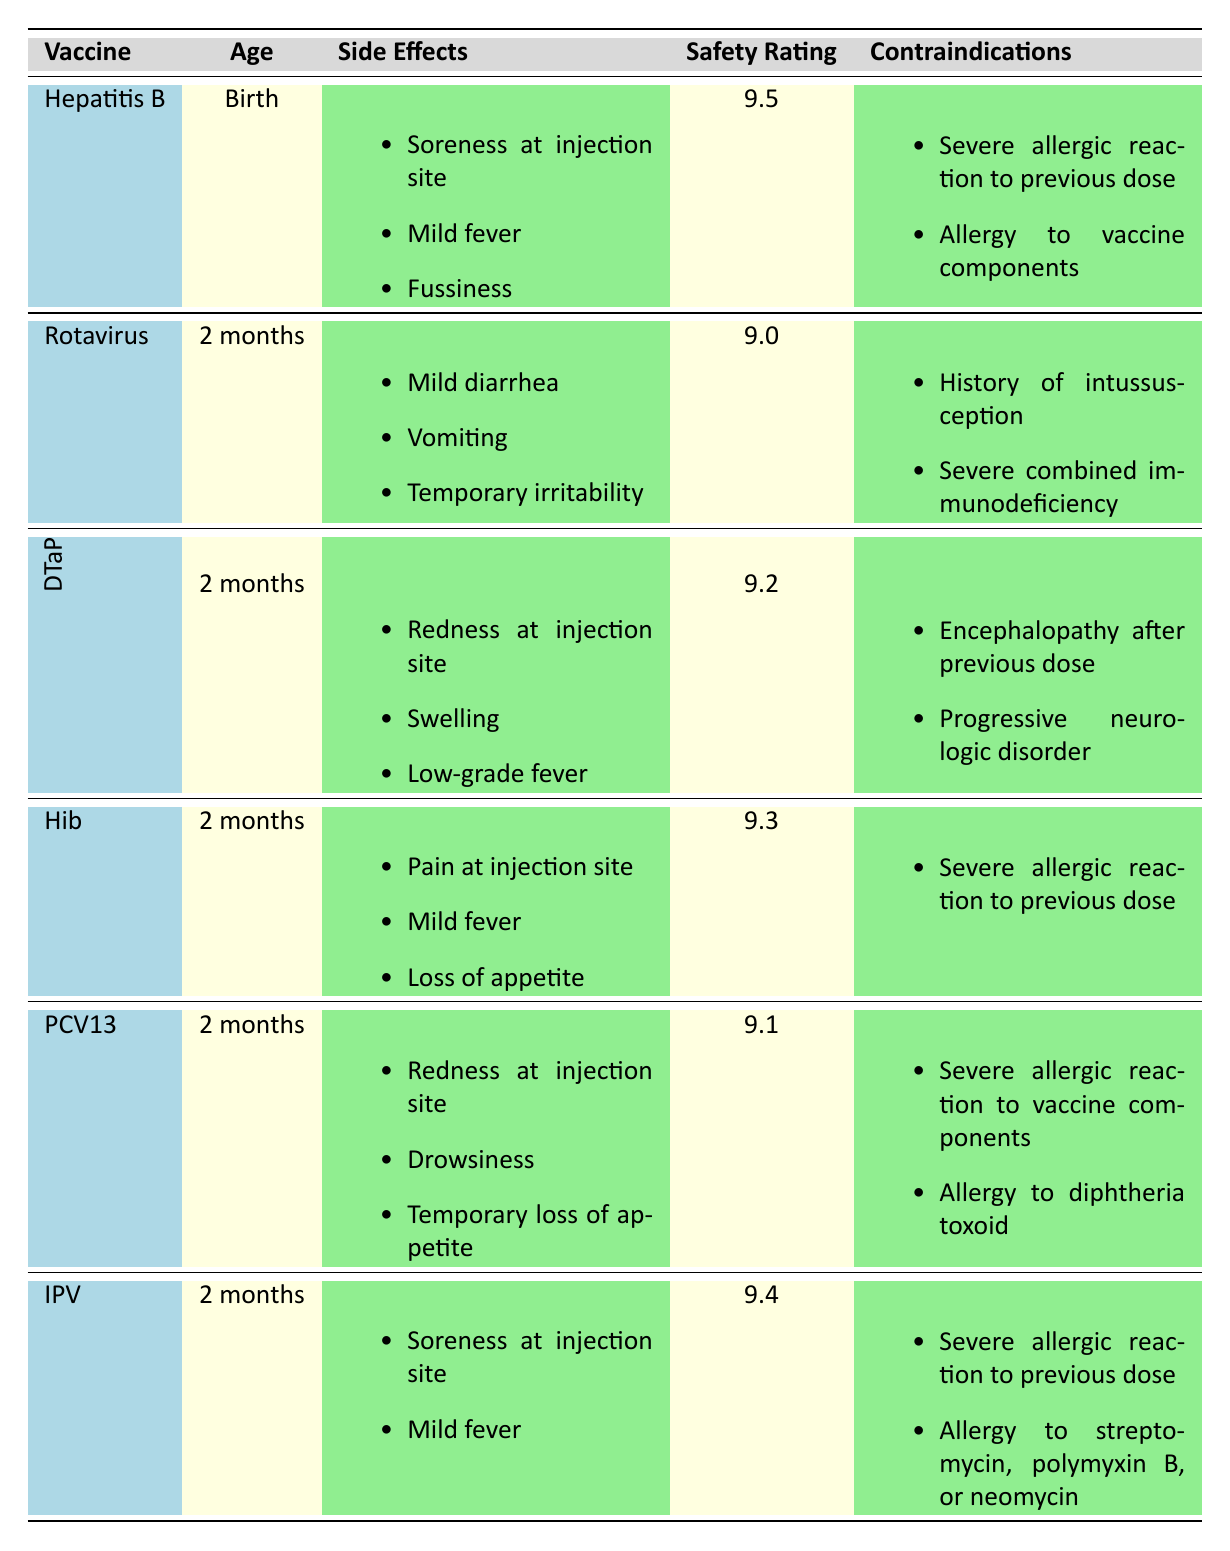What are the potential side effects of the Rotavirus vaccine? The table lists the potential side effects of the Rotavirus vaccine as mild diarrhea, vomiting, and temporary irritability, which are extracted directly from the corresponding row.
Answer: Mild diarrhea, vomiting, temporary irritability Which vaccines are recommended to be given at 2 months? By examining the recommended age column, we identify the vaccines listed for 2 months: Rotavirus, DTaP, Hib, PCV13, and IPV.
Answer: Rotavirus, DTaP, Hib, PCV13, IPV Is it true that Hepatitis B vaccine has a safety rating above 9? The safety rating for the Hepatitis B vaccine is 9.5, which is indeed above 9. Thus, the statement is confirmed as true.
Answer: Yes What are the contraindications for the PCV13 vaccine? The contraindications listed under the PCV13 row are a severe allergic reaction to vaccine components and an allergy to diphtheria toxoid. These are directly cited from the table.
Answer: Severe allergic reaction to vaccine components, allergy to diphtheria toxoid Which vaccine has the highest safety rating and what is the rating? Looking at the safety ratings, Hepatitis B has the highest rating at 9.5, as seen in its row. This involves comparing all safety ratings in the table.
Answer: 9.5 Determine the average safety rating for the vaccines recommended at 2 months. The vaccines for 2 months include Rotavirus (9.0), DTaP (9.2), Hib (9.3), PCV13 (9.1), and IPV (9.4). Adding these ratings: 9.0 + 9.2 + 9.3 + 9.1 + 9.4 = 45. The average rating is then 45 divided by 5, which equals 9.
Answer: 9 Is there a vaccine that has the potential side effect of soreness at the injection site? Yes, the Hepatitis B and IPV vaccines both list soreness at the injection site as a potential side effect, indicating their shared occurrence. This is verified by reading the side effects column.
Answer: Yes What is the recommended age for the DTaP vaccine? The table specifies that the recommended age for the DTaP vaccine is 2 months as seen in its corresponding row.
Answer: 2 months Which vaccines are contraindicated in the presence of a severe allergic reaction to a previous dose? The contraindications for the Hepatitis B and IPV vaccines list severe allergic reaction to a previous dose. This is derived from checking the contraindications for each relevant vaccine.
Answer: Hepatitis B, IPV 